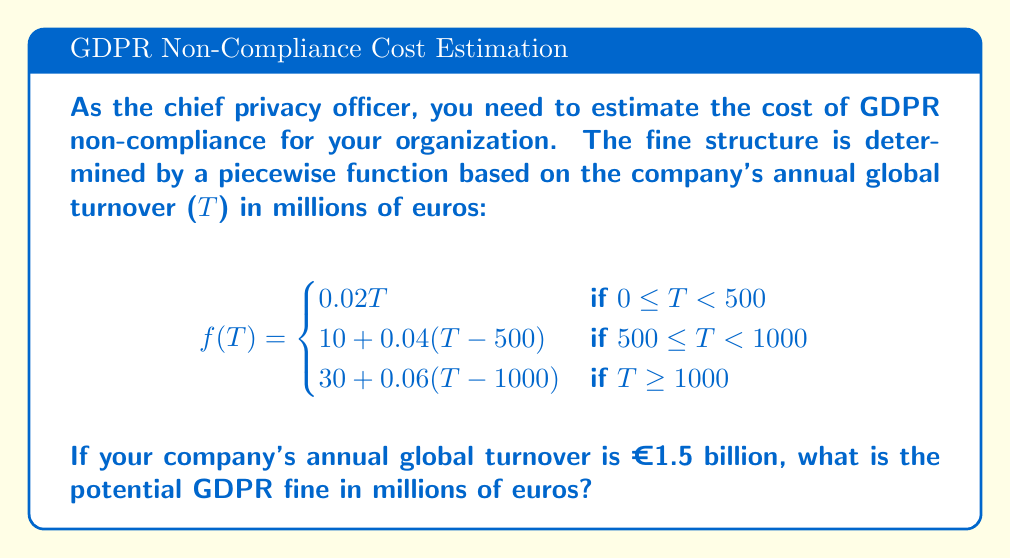Can you solve this math problem? To solve this problem, we need to follow these steps:

1. Identify the correct piece of the function to use:
   Our company's turnover T = 1500 million euros, which falls in the third case (T ≥ 1000).

2. Use the appropriate formula:
   $$f(T) = 30 + 0.06(T-1000)$$

3. Substitute T = 1500 into the formula:
   $$f(1500) = 30 + 0.06(1500-1000)$$

4. Simplify:
   $$f(1500) = 30 + 0.06(500)$$
   $$f(1500) = 30 + 30$$
   $$f(1500) = 60$$

Therefore, the potential GDPR fine for the company with an annual global turnover of €1.5 billion is €60 million.
Answer: €60 million 